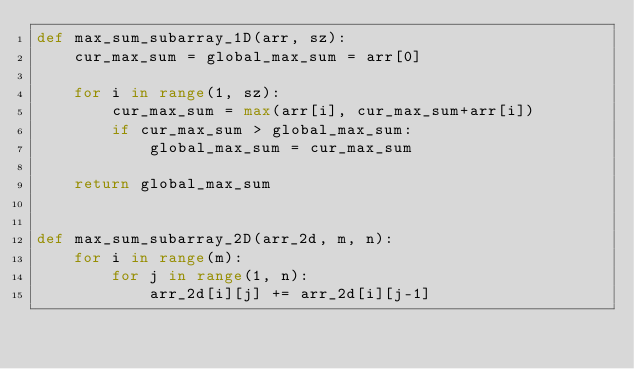Convert code to text. <code><loc_0><loc_0><loc_500><loc_500><_Python_>def max_sum_subarray_1D(arr, sz):
    cur_max_sum = global_max_sum = arr[0]

    for i in range(1, sz):
        cur_max_sum = max(arr[i], cur_max_sum+arr[i])
        if cur_max_sum > global_max_sum:
            global_max_sum = cur_max_sum

    return global_max_sum


def max_sum_subarray_2D(arr_2d, m, n):
    for i in range(m):
        for j in range(1, n):
            arr_2d[i][j] += arr_2d[i][j-1]
</code> 